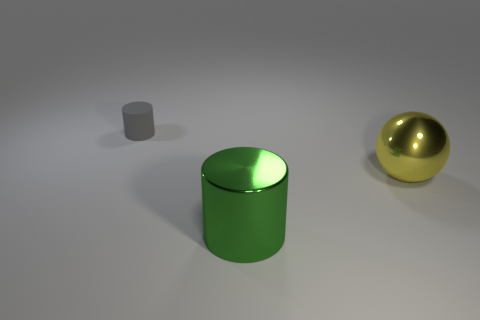Add 1 large green metallic cylinders. How many objects exist? 4 Subtract all cylinders. How many objects are left? 1 Add 2 small gray rubber objects. How many small gray rubber objects exist? 3 Subtract 0 cyan cylinders. How many objects are left? 3 Subtract all brown cylinders. Subtract all cyan cubes. How many cylinders are left? 2 Subtract all large brown matte things. Subtract all big yellow metallic objects. How many objects are left? 2 Add 3 tiny gray rubber objects. How many tiny gray rubber objects are left? 4 